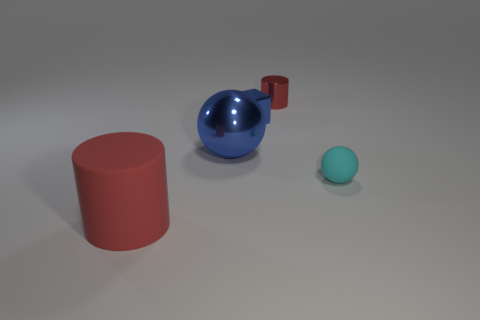There is a matte object that is the same color as the tiny cylinder; what is its shape?
Your answer should be very brief. Cylinder. Are there any tiny purple rubber spheres?
Ensure brevity in your answer.  No. Are there the same number of large objects that are to the right of the tiny red cylinder and cubes?
Keep it short and to the point. No. How many other things are there of the same shape as the small cyan thing?
Provide a succinct answer. 1. What is the shape of the tiny blue shiny object?
Give a very brief answer. Cube. Is the tiny red cylinder made of the same material as the small cyan sphere?
Give a very brief answer. No. Are there the same number of blue shiny objects right of the small blue shiny block and blue metal balls that are left of the tiny metallic cylinder?
Give a very brief answer. No. There is a cylinder that is behind the large thing behind the large red cylinder; are there any large matte cylinders that are on the left side of it?
Your answer should be very brief. Yes. Is the size of the rubber ball the same as the metallic ball?
Provide a succinct answer. No. What is the color of the shiny object that is in front of the small metallic block behind the small cyan ball right of the big red object?
Offer a very short reply. Blue. 